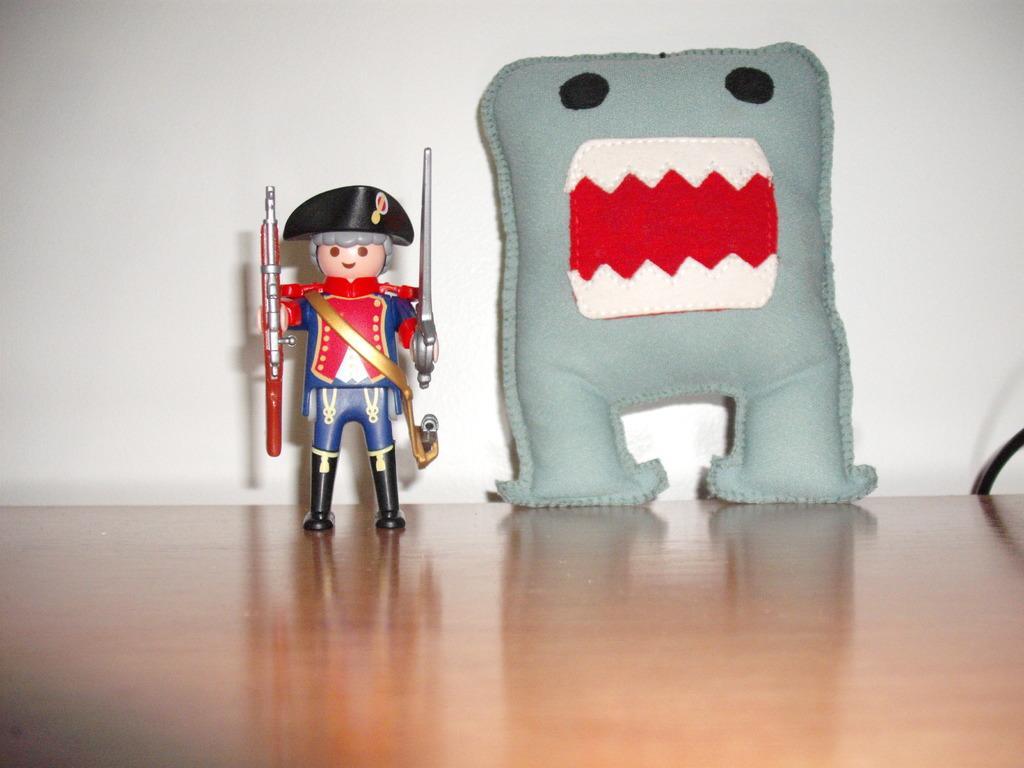How would you summarize this image in a sentence or two? In this picture we can see a toy and a pillow on the platform and we can see a wall in the background. 